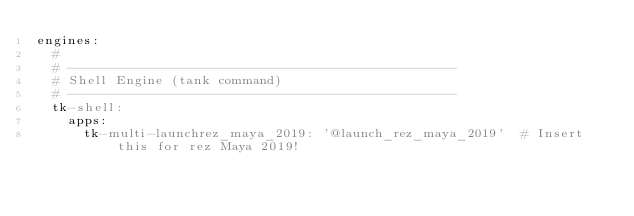<code> <loc_0><loc_0><loc_500><loc_500><_YAML_>engines:
  #
  # -------------------------------------------------
  # Shell Engine (tank command)
  # -------------------------------------------------
  tk-shell:
    apps:
      tk-multi-launchrez_maya_2019: '@launch_rez_maya_2019'  # Insert this for rez Maya 2019!</code> 